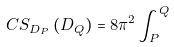<formula> <loc_0><loc_0><loc_500><loc_500>C S _ { D _ { P } } \left ( D _ { Q } \right ) = 8 \pi ^ { 2 } \int \nolimits _ { P } ^ { Q }</formula> 